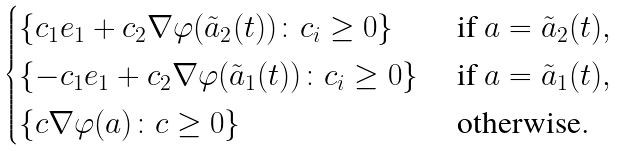Convert formula to latex. <formula><loc_0><loc_0><loc_500><loc_500>\begin{cases} \{ c _ { 1 } e _ { 1 } + c _ { 2 } \nabla \varphi ( \tilde { a } _ { 2 } ( t ) ) \colon c _ { i } \geq 0 \} & \text { if $a=\tilde{a}_{2}(t)$} , \\ \{ - c _ { 1 } e _ { 1 } + c _ { 2 } \nabla \varphi ( \tilde { a } _ { 1 } ( t ) ) \colon c _ { i } \geq 0 \} & \text { if $a=\tilde{a}_{1}(t)$} , \\ \{ c \nabla \varphi ( a ) \colon c \geq 0 \} & \text { otherwise} . \end{cases}</formula> 